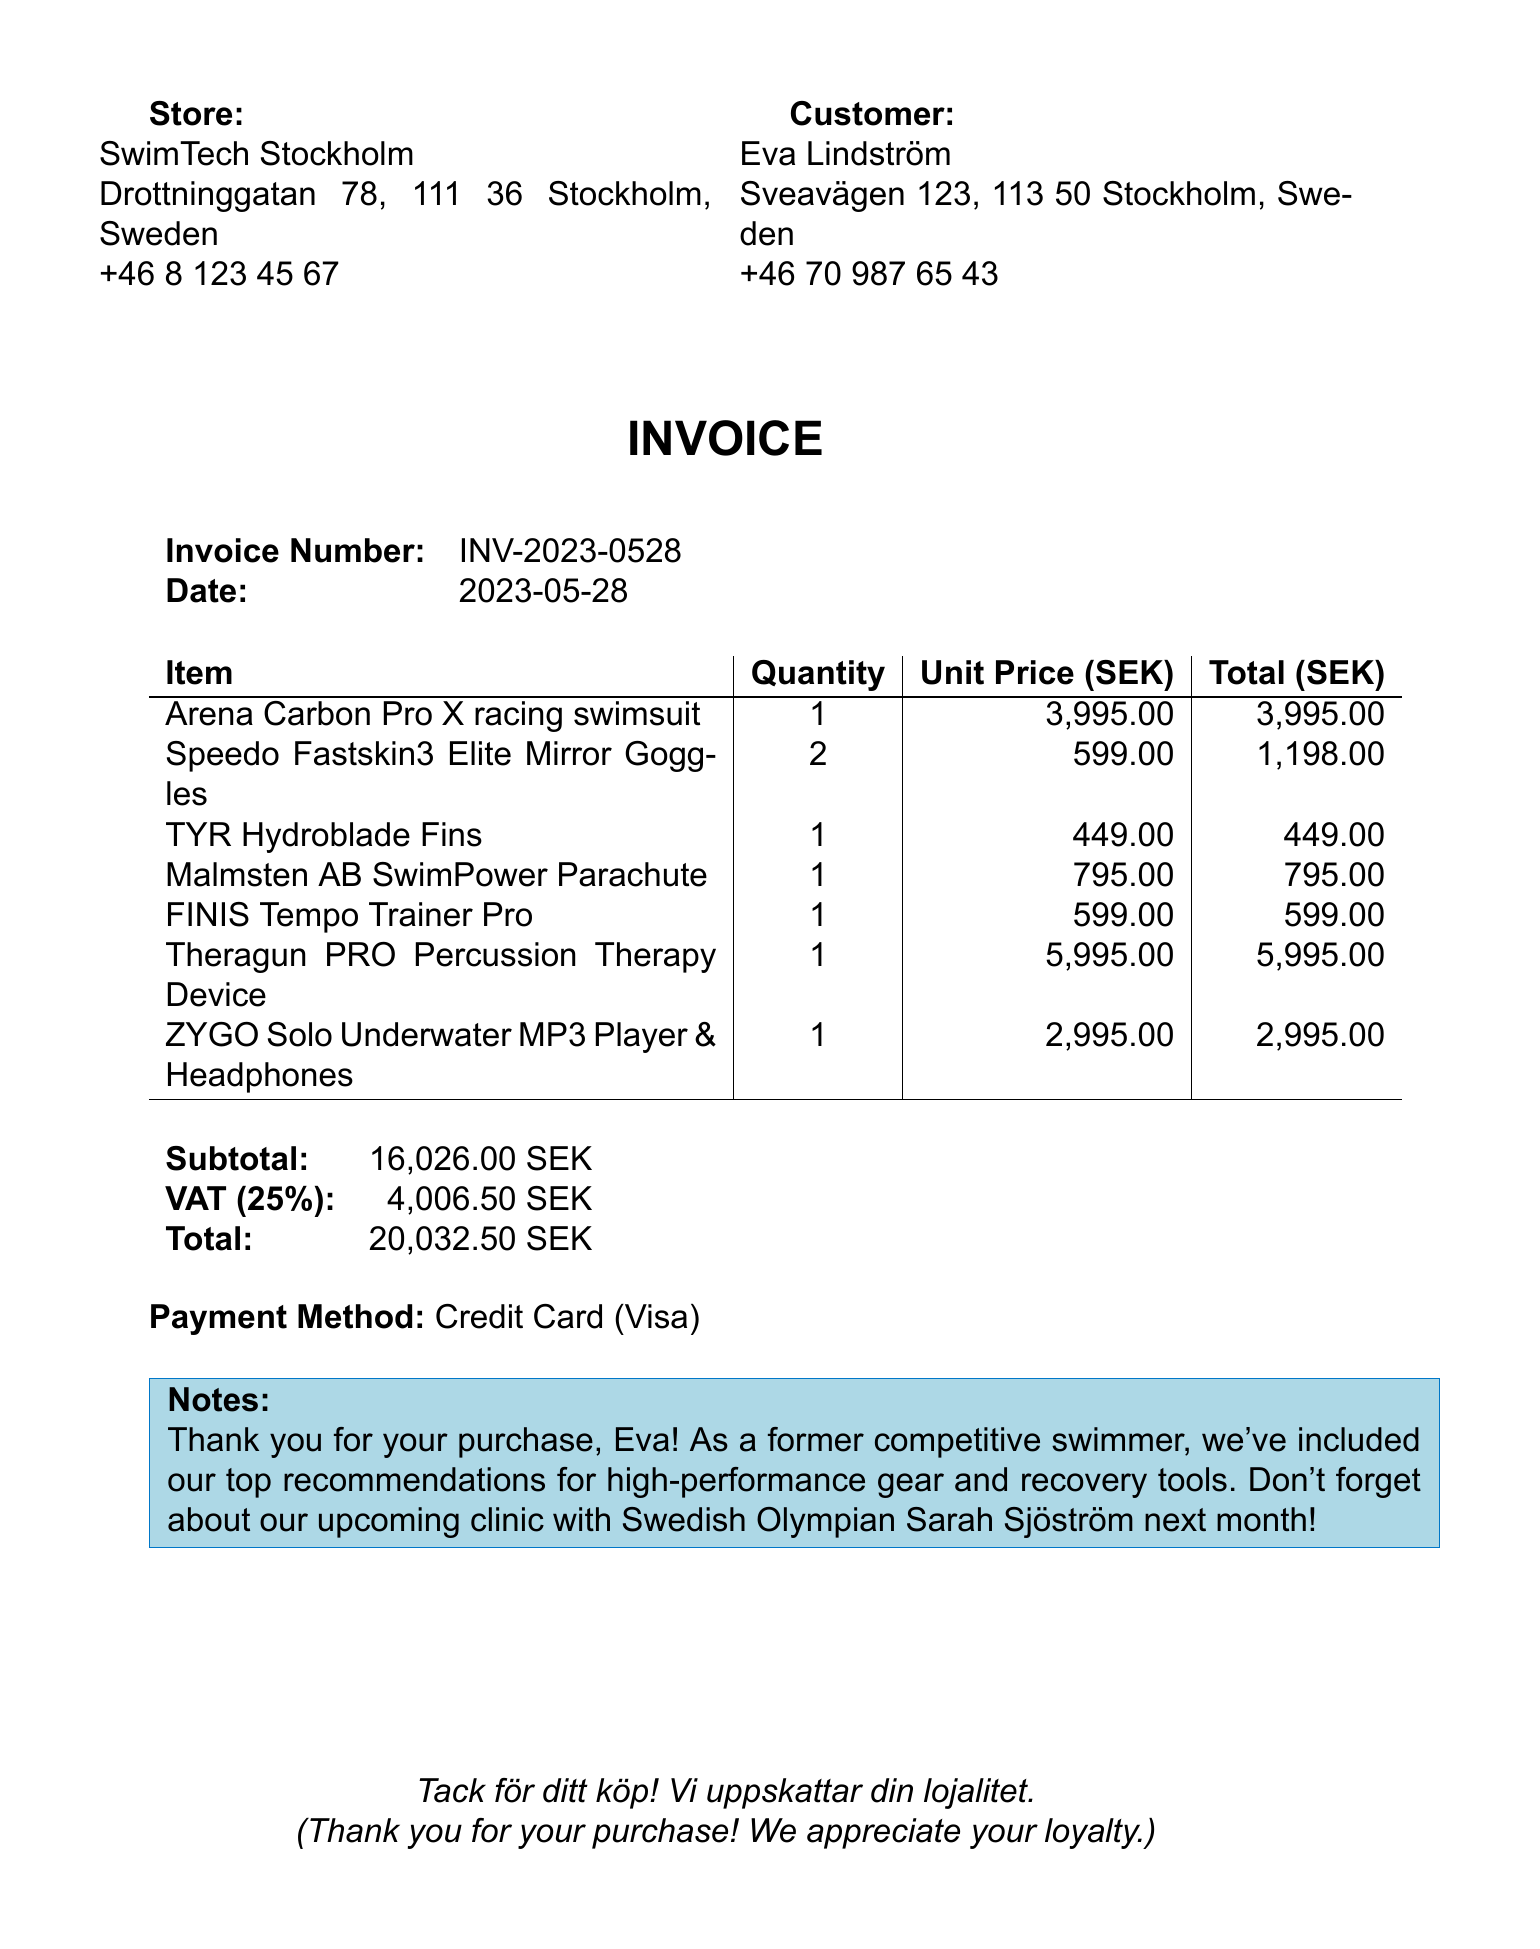What is the store name? The store name is listed at the top of the invoice, which is SwimTech Stockholm.
Answer: SwimTech Stockholm What is the invoice number? The invoice number is a unique identifier for this transaction, which is mentioned in the document.
Answer: INV-2023-0528 What is the total amount due? The total amount due is calculated at the end of the invoice, including VAT.
Answer: 20,032.50 SEK How many Speedo Fastskin3 Elite Mirror Goggles were purchased? The quantity of goggles is specified in the items section of the invoice.
Answer: 2 What is the VAT rate applied? The VAT rate can be found alongside the VAT amount, indicating the percentage charged.
Answer: 25% What item has the highest unit price? The item with the highest unit price is singled out in the list of items.
Answer: Theragun PRO Percussion Therapy Device What is the payment method used? The payment method is specified in the invoice under the payment section.
Answer: Credit Card (Visa) What does the note at the bottom of the invoice mention about a clinic? The note includes information about an upcoming event involving a prominent swimmer.
Answer: Upcoming clinic with Swedish Olympian Sarah Sjöström How many items are listed on the invoice? The number of items can be counted in the items section of the invoice.
Answer: 7 items 